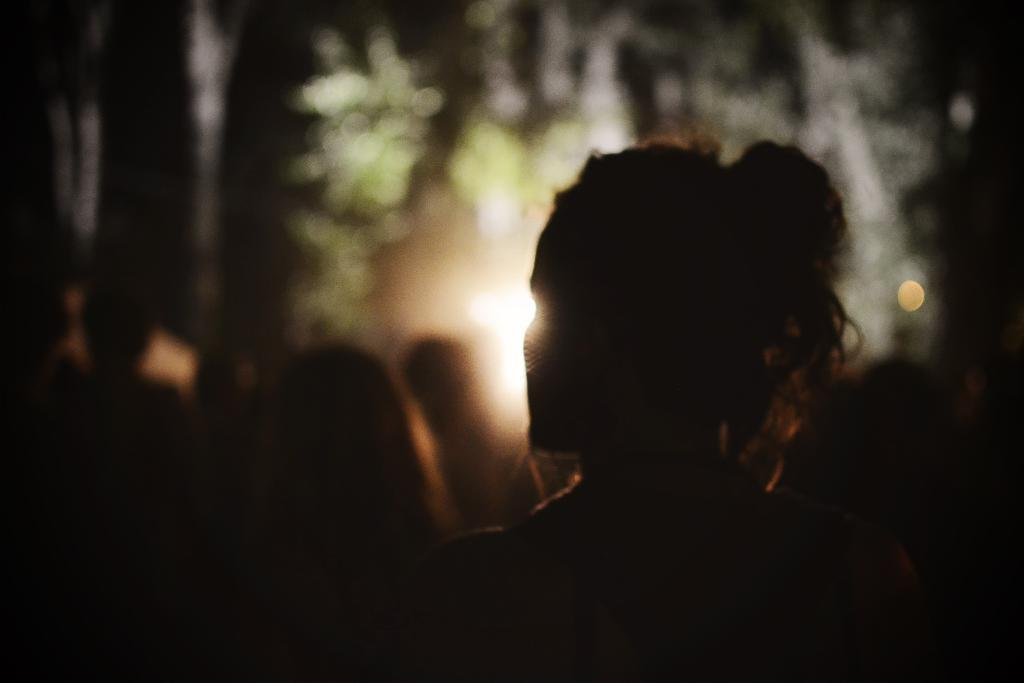What can be observed about the people in the image? There are people standing in the image. Can you describe the environment in which the people are standing? The people are standing in a dark environment. What can be seen in the distance in the image? There are trees visible in the distance. Is there any source of light in the image? There is a light focus in the image, but it is not clearly visible. What type of straw is being used by the people in the image? There is no straw present in the image. How many legs does the harmony have in the image? There is no harmony present in the image, so it does not have any legs. 